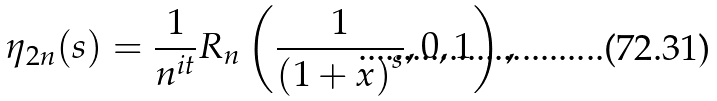<formula> <loc_0><loc_0><loc_500><loc_500>\eta _ { 2 n } ( s ) = { \frac { 1 } { n ^ { i t } } } R _ { n } \left ( { \frac { 1 } { { ( 1 + x ) } ^ { s } } } , 0 , 1 \right ) ,</formula> 